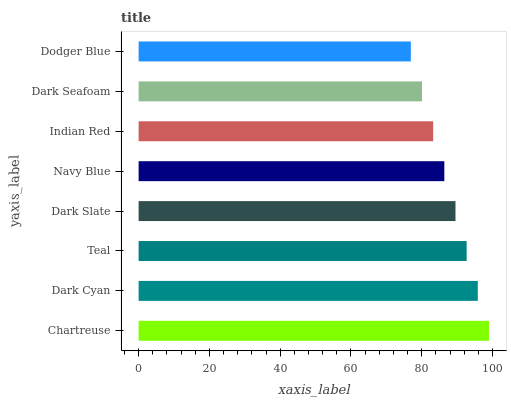Is Dodger Blue the minimum?
Answer yes or no. Yes. Is Chartreuse the maximum?
Answer yes or no. Yes. Is Dark Cyan the minimum?
Answer yes or no. No. Is Dark Cyan the maximum?
Answer yes or no. No. Is Chartreuse greater than Dark Cyan?
Answer yes or no. Yes. Is Dark Cyan less than Chartreuse?
Answer yes or no. Yes. Is Dark Cyan greater than Chartreuse?
Answer yes or no. No. Is Chartreuse less than Dark Cyan?
Answer yes or no. No. Is Dark Slate the high median?
Answer yes or no. Yes. Is Navy Blue the low median?
Answer yes or no. Yes. Is Chartreuse the high median?
Answer yes or no. No. Is Chartreuse the low median?
Answer yes or no. No. 